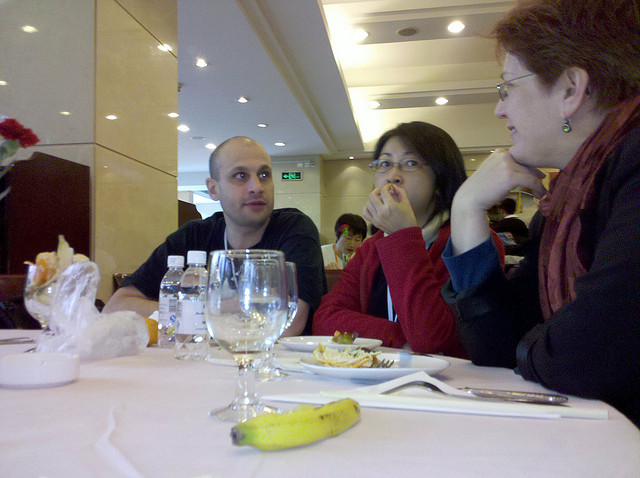<image>What point in the meal are these women taking pictures? It is ambiguous what point in the meal these women are taking pictures. It could be during dessert or any other time during the meal. What kind of wine is in the glasses? I don't know what kind of wine is in the glasses. It can be white wine. What point in the meal are these women taking pictures? I don't know at what point in the meal these women are taking pictures. It could be during the meal, after the meal, or during the dessert. What kind of wine is in the glasses? I am not sure what kind of wine is in the glasses. It can be either 'white' or 'white wine'. 